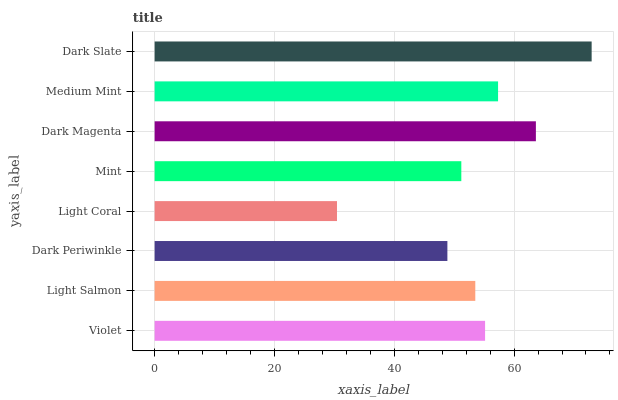Is Light Coral the minimum?
Answer yes or no. Yes. Is Dark Slate the maximum?
Answer yes or no. Yes. Is Light Salmon the minimum?
Answer yes or no. No. Is Light Salmon the maximum?
Answer yes or no. No. Is Violet greater than Light Salmon?
Answer yes or no. Yes. Is Light Salmon less than Violet?
Answer yes or no. Yes. Is Light Salmon greater than Violet?
Answer yes or no. No. Is Violet less than Light Salmon?
Answer yes or no. No. Is Violet the high median?
Answer yes or no. Yes. Is Light Salmon the low median?
Answer yes or no. Yes. Is Dark Slate the high median?
Answer yes or no. No. Is Dark Magenta the low median?
Answer yes or no. No. 